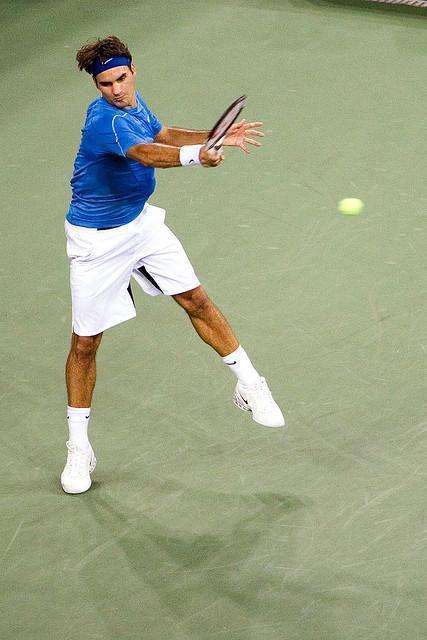How many people are in the photo?
Give a very brief answer. 1. How many elephant trunks can you see in the picture?
Give a very brief answer. 0. 